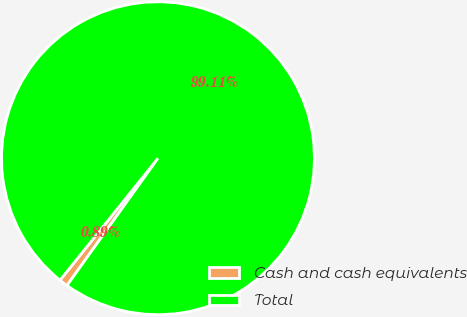Convert chart to OTSL. <chart><loc_0><loc_0><loc_500><loc_500><pie_chart><fcel>Cash and cash equivalents<fcel>Total<nl><fcel>0.89%<fcel>99.11%<nl></chart> 